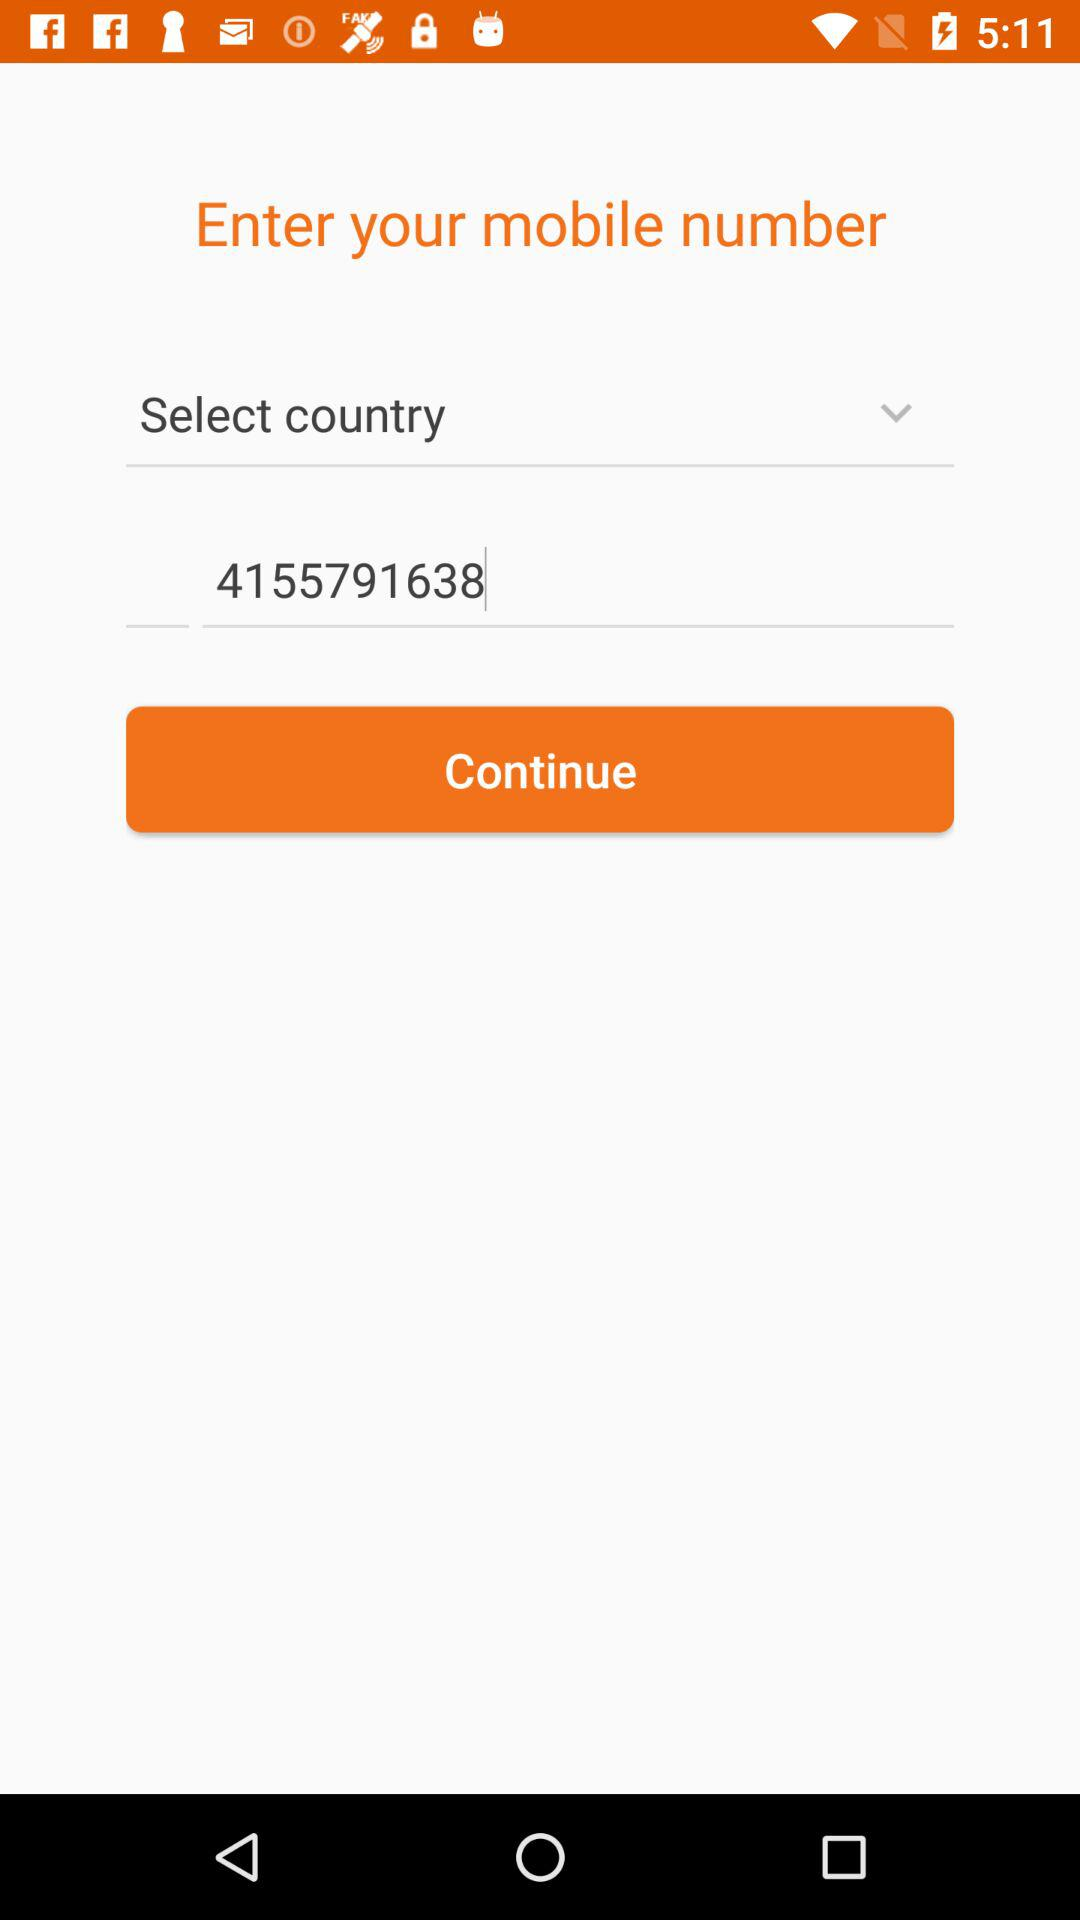What is the mobile number? The mobile number is 4155791638. 